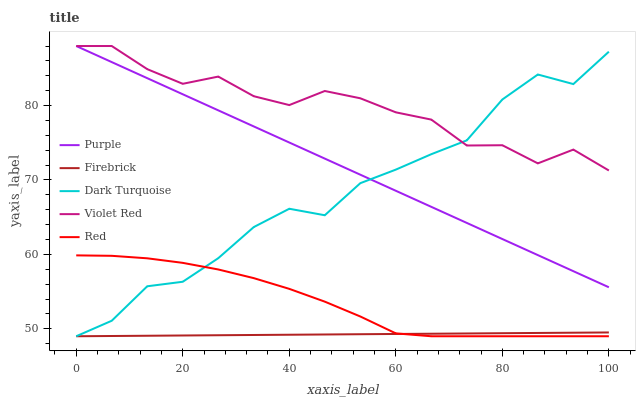Does Firebrick have the minimum area under the curve?
Answer yes or no. Yes. Does Violet Red have the maximum area under the curve?
Answer yes or no. Yes. Does Dark Turquoise have the minimum area under the curve?
Answer yes or no. No. Does Dark Turquoise have the maximum area under the curve?
Answer yes or no. No. Is Firebrick the smoothest?
Answer yes or no. Yes. Is Dark Turquoise the roughest?
Answer yes or no. Yes. Is Dark Turquoise the smoothest?
Answer yes or no. No. Is Firebrick the roughest?
Answer yes or no. No. Does Dark Turquoise have the lowest value?
Answer yes or no. Yes. Does Violet Red have the lowest value?
Answer yes or no. No. Does Violet Red have the highest value?
Answer yes or no. Yes. Does Dark Turquoise have the highest value?
Answer yes or no. No. Is Red less than Violet Red?
Answer yes or no. Yes. Is Purple greater than Red?
Answer yes or no. Yes. Does Dark Turquoise intersect Violet Red?
Answer yes or no. Yes. Is Dark Turquoise less than Violet Red?
Answer yes or no. No. Is Dark Turquoise greater than Violet Red?
Answer yes or no. No. Does Red intersect Violet Red?
Answer yes or no. No. 